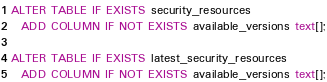<code> <loc_0><loc_0><loc_500><loc_500><_SQL_>ALTER TABLE IF EXISTS security_resources
  ADD COLUMN IF NOT EXISTS available_versions text[];

ALTER TABLE IF EXISTS latest_security_resources
  ADD COLUMN IF NOT EXISTS available_versions text[];
</code> 